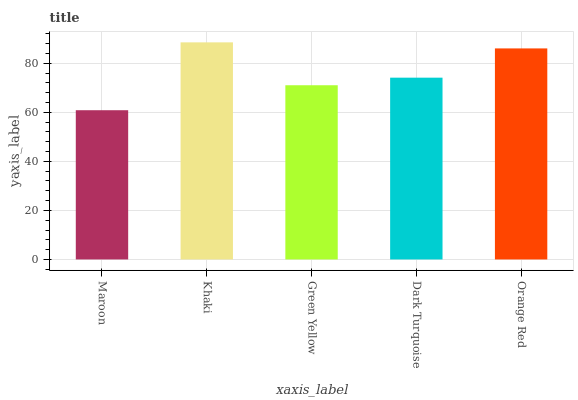Is Green Yellow the minimum?
Answer yes or no. No. Is Green Yellow the maximum?
Answer yes or no. No. Is Khaki greater than Green Yellow?
Answer yes or no. Yes. Is Green Yellow less than Khaki?
Answer yes or no. Yes. Is Green Yellow greater than Khaki?
Answer yes or no. No. Is Khaki less than Green Yellow?
Answer yes or no. No. Is Dark Turquoise the high median?
Answer yes or no. Yes. Is Dark Turquoise the low median?
Answer yes or no. Yes. Is Maroon the high median?
Answer yes or no. No. Is Khaki the low median?
Answer yes or no. No. 